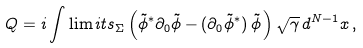Convert formula to latex. <formula><loc_0><loc_0><loc_500><loc_500>Q = i \int \lim i t s _ { \Sigma } \left ( \tilde { \phi } ^ { * } \partial _ { 0 } \tilde { \phi } - ( \partial _ { 0 } \tilde { \phi } ^ { * } ) \, \tilde { \phi } \, \right ) \sqrt { \gamma } \, d ^ { N - 1 } x \, ,</formula> 